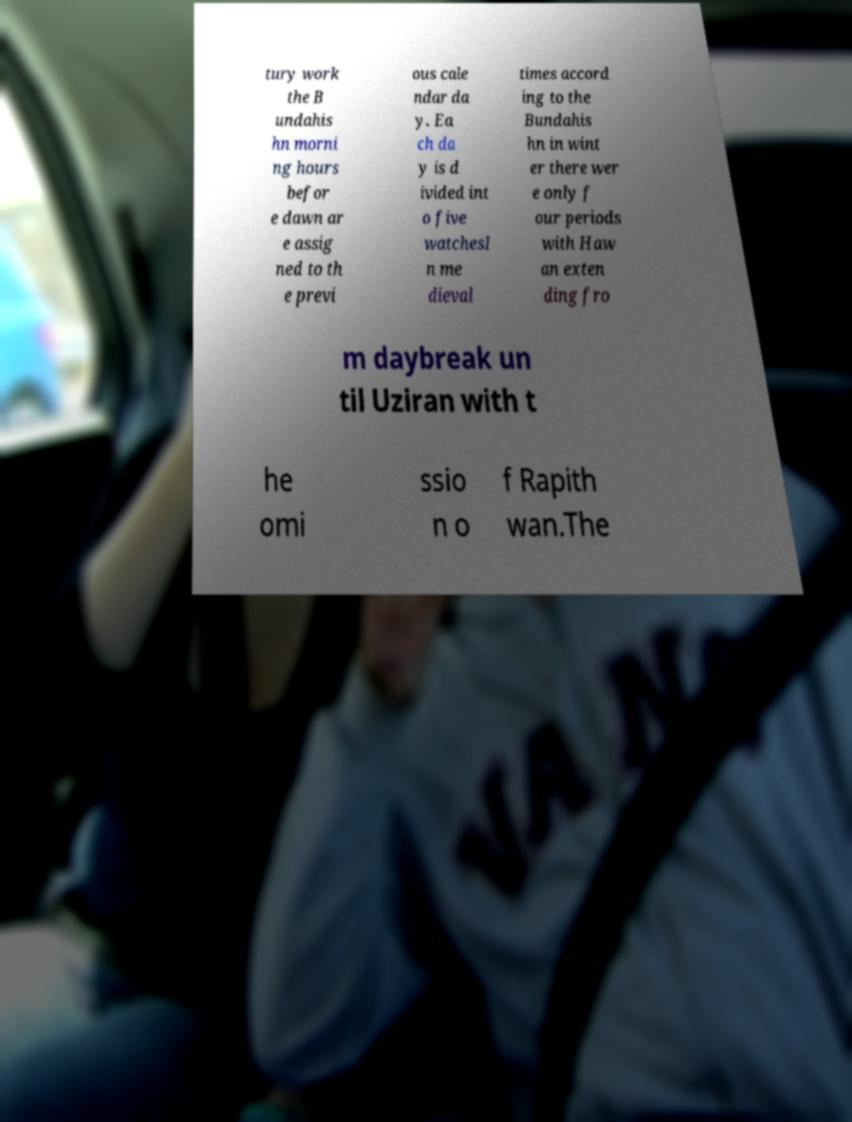I need the written content from this picture converted into text. Can you do that? tury work the B undahis hn morni ng hours befor e dawn ar e assig ned to th e previ ous cale ndar da y. Ea ch da y is d ivided int o five watchesI n me dieval times accord ing to the Bundahis hn in wint er there wer e only f our periods with Haw an exten ding fro m daybreak un til Uziran with t he omi ssio n o f Rapith wan.The 